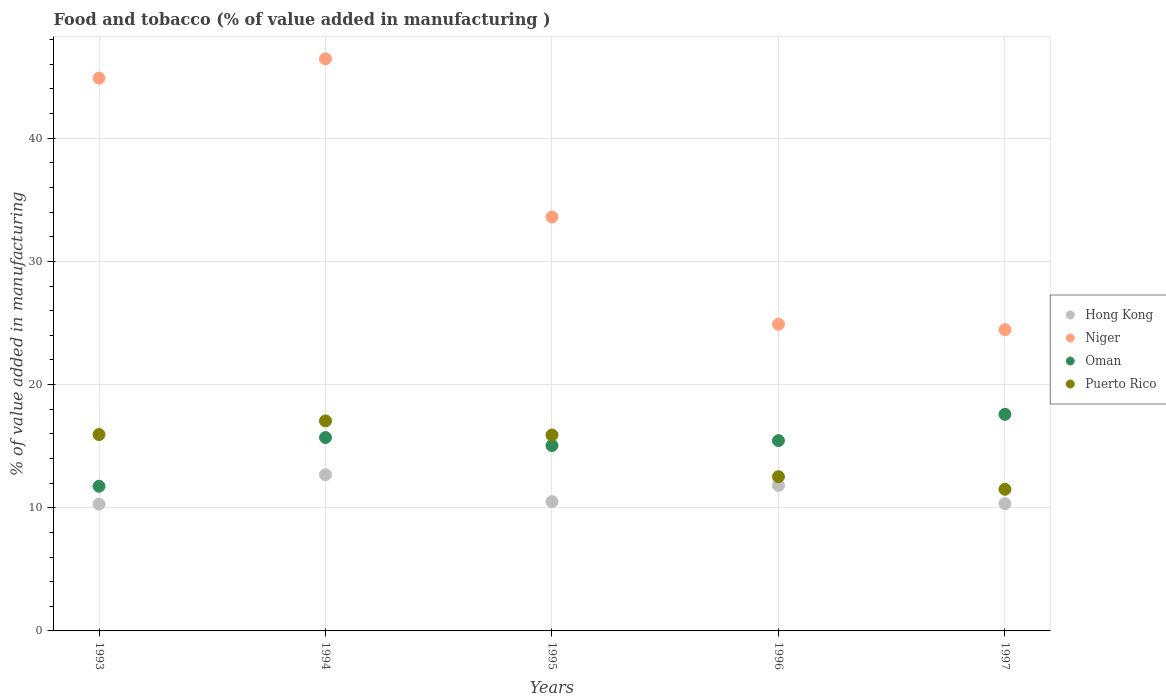How many different coloured dotlines are there?
Provide a succinct answer. 4. What is the value added in manufacturing food and tobacco in Oman in 1997?
Offer a very short reply. 17.58. Across all years, what is the maximum value added in manufacturing food and tobacco in Puerto Rico?
Ensure brevity in your answer.  17.05. Across all years, what is the minimum value added in manufacturing food and tobacco in Niger?
Ensure brevity in your answer.  24.46. In which year was the value added in manufacturing food and tobacco in Puerto Rico maximum?
Keep it short and to the point. 1994. In which year was the value added in manufacturing food and tobacco in Puerto Rico minimum?
Keep it short and to the point. 1997. What is the total value added in manufacturing food and tobacco in Puerto Rico in the graph?
Offer a very short reply. 72.92. What is the difference between the value added in manufacturing food and tobacco in Puerto Rico in 1995 and that in 1996?
Your answer should be very brief. 3.38. What is the difference between the value added in manufacturing food and tobacco in Niger in 1995 and the value added in manufacturing food and tobacco in Oman in 1996?
Keep it short and to the point. 18.16. What is the average value added in manufacturing food and tobacco in Oman per year?
Provide a short and direct response. 15.1. In the year 1997, what is the difference between the value added in manufacturing food and tobacco in Hong Kong and value added in manufacturing food and tobacco in Niger?
Ensure brevity in your answer.  -14.12. What is the ratio of the value added in manufacturing food and tobacco in Puerto Rico in 1994 to that in 1995?
Your response must be concise. 1.07. What is the difference between the highest and the second highest value added in manufacturing food and tobacco in Oman?
Keep it short and to the point. 1.88. What is the difference between the highest and the lowest value added in manufacturing food and tobacco in Oman?
Your answer should be very brief. 5.84. In how many years, is the value added in manufacturing food and tobacco in Oman greater than the average value added in manufacturing food and tobacco in Oman taken over all years?
Provide a succinct answer. 3. Is it the case that in every year, the sum of the value added in manufacturing food and tobacco in Hong Kong and value added in manufacturing food and tobacco in Puerto Rico  is greater than the value added in manufacturing food and tobacco in Niger?
Keep it short and to the point. No. Does the value added in manufacturing food and tobacco in Hong Kong monotonically increase over the years?
Provide a short and direct response. No. Is the value added in manufacturing food and tobacco in Niger strictly greater than the value added in manufacturing food and tobacco in Puerto Rico over the years?
Ensure brevity in your answer.  Yes. How many years are there in the graph?
Offer a terse response. 5. Does the graph contain any zero values?
Give a very brief answer. No. Does the graph contain grids?
Your answer should be compact. Yes. Where does the legend appear in the graph?
Your answer should be compact. Center right. How many legend labels are there?
Your answer should be very brief. 4. What is the title of the graph?
Provide a succinct answer. Food and tobacco (% of value added in manufacturing ). Does "Latin America(developing only)" appear as one of the legend labels in the graph?
Your answer should be very brief. No. What is the label or title of the Y-axis?
Your response must be concise. % of value added in manufacturing. What is the % of value added in manufacturing of Hong Kong in 1993?
Your answer should be very brief. 10.29. What is the % of value added in manufacturing of Niger in 1993?
Offer a very short reply. 44.87. What is the % of value added in manufacturing in Oman in 1993?
Ensure brevity in your answer.  11.75. What is the % of value added in manufacturing of Puerto Rico in 1993?
Provide a short and direct response. 15.94. What is the % of value added in manufacturing in Hong Kong in 1994?
Keep it short and to the point. 12.68. What is the % of value added in manufacturing of Niger in 1994?
Your answer should be very brief. 46.44. What is the % of value added in manufacturing in Oman in 1994?
Keep it short and to the point. 15.7. What is the % of value added in manufacturing in Puerto Rico in 1994?
Make the answer very short. 17.05. What is the % of value added in manufacturing in Hong Kong in 1995?
Make the answer very short. 10.5. What is the % of value added in manufacturing of Niger in 1995?
Make the answer very short. 33.6. What is the % of value added in manufacturing in Oman in 1995?
Ensure brevity in your answer.  15.05. What is the % of value added in manufacturing in Puerto Rico in 1995?
Provide a short and direct response. 15.91. What is the % of value added in manufacturing in Hong Kong in 1996?
Provide a succinct answer. 11.8. What is the % of value added in manufacturing of Niger in 1996?
Keep it short and to the point. 24.9. What is the % of value added in manufacturing in Oman in 1996?
Provide a short and direct response. 15.45. What is the % of value added in manufacturing in Puerto Rico in 1996?
Offer a terse response. 12.52. What is the % of value added in manufacturing of Hong Kong in 1997?
Make the answer very short. 10.33. What is the % of value added in manufacturing of Niger in 1997?
Keep it short and to the point. 24.46. What is the % of value added in manufacturing of Oman in 1997?
Make the answer very short. 17.58. What is the % of value added in manufacturing in Puerto Rico in 1997?
Make the answer very short. 11.5. Across all years, what is the maximum % of value added in manufacturing of Hong Kong?
Your answer should be compact. 12.68. Across all years, what is the maximum % of value added in manufacturing of Niger?
Provide a short and direct response. 46.44. Across all years, what is the maximum % of value added in manufacturing of Oman?
Give a very brief answer. 17.58. Across all years, what is the maximum % of value added in manufacturing in Puerto Rico?
Offer a terse response. 17.05. Across all years, what is the minimum % of value added in manufacturing in Hong Kong?
Provide a succinct answer. 10.29. Across all years, what is the minimum % of value added in manufacturing of Niger?
Offer a very short reply. 24.46. Across all years, what is the minimum % of value added in manufacturing in Oman?
Your response must be concise. 11.75. Across all years, what is the minimum % of value added in manufacturing of Puerto Rico?
Your answer should be very brief. 11.5. What is the total % of value added in manufacturing of Hong Kong in the graph?
Give a very brief answer. 55.61. What is the total % of value added in manufacturing of Niger in the graph?
Your answer should be very brief. 174.27. What is the total % of value added in manufacturing in Oman in the graph?
Keep it short and to the point. 75.52. What is the total % of value added in manufacturing in Puerto Rico in the graph?
Your answer should be compact. 72.92. What is the difference between the % of value added in manufacturing of Hong Kong in 1993 and that in 1994?
Offer a very short reply. -2.39. What is the difference between the % of value added in manufacturing of Niger in 1993 and that in 1994?
Offer a terse response. -1.57. What is the difference between the % of value added in manufacturing in Oman in 1993 and that in 1994?
Your response must be concise. -3.95. What is the difference between the % of value added in manufacturing of Puerto Rico in 1993 and that in 1994?
Your answer should be compact. -1.1. What is the difference between the % of value added in manufacturing in Hong Kong in 1993 and that in 1995?
Give a very brief answer. -0.21. What is the difference between the % of value added in manufacturing of Niger in 1993 and that in 1995?
Your response must be concise. 11.27. What is the difference between the % of value added in manufacturing of Oman in 1993 and that in 1995?
Make the answer very short. -3.31. What is the difference between the % of value added in manufacturing of Puerto Rico in 1993 and that in 1995?
Provide a short and direct response. 0.04. What is the difference between the % of value added in manufacturing in Hong Kong in 1993 and that in 1996?
Offer a terse response. -1.51. What is the difference between the % of value added in manufacturing in Niger in 1993 and that in 1996?
Your answer should be compact. 19.98. What is the difference between the % of value added in manufacturing in Oman in 1993 and that in 1996?
Provide a succinct answer. -3.7. What is the difference between the % of value added in manufacturing of Puerto Rico in 1993 and that in 1996?
Offer a very short reply. 3.42. What is the difference between the % of value added in manufacturing of Hong Kong in 1993 and that in 1997?
Your answer should be very brief. -0.04. What is the difference between the % of value added in manufacturing in Niger in 1993 and that in 1997?
Offer a terse response. 20.42. What is the difference between the % of value added in manufacturing in Oman in 1993 and that in 1997?
Make the answer very short. -5.84. What is the difference between the % of value added in manufacturing of Puerto Rico in 1993 and that in 1997?
Ensure brevity in your answer.  4.44. What is the difference between the % of value added in manufacturing in Hong Kong in 1994 and that in 1995?
Make the answer very short. 2.18. What is the difference between the % of value added in manufacturing in Niger in 1994 and that in 1995?
Offer a terse response. 12.84. What is the difference between the % of value added in manufacturing in Oman in 1994 and that in 1995?
Give a very brief answer. 0.65. What is the difference between the % of value added in manufacturing of Puerto Rico in 1994 and that in 1995?
Keep it short and to the point. 1.14. What is the difference between the % of value added in manufacturing of Hong Kong in 1994 and that in 1996?
Keep it short and to the point. 0.88. What is the difference between the % of value added in manufacturing in Niger in 1994 and that in 1996?
Your response must be concise. 21.55. What is the difference between the % of value added in manufacturing of Oman in 1994 and that in 1996?
Your answer should be compact. 0.25. What is the difference between the % of value added in manufacturing in Puerto Rico in 1994 and that in 1996?
Your response must be concise. 4.53. What is the difference between the % of value added in manufacturing of Hong Kong in 1994 and that in 1997?
Ensure brevity in your answer.  2.35. What is the difference between the % of value added in manufacturing of Niger in 1994 and that in 1997?
Your response must be concise. 21.99. What is the difference between the % of value added in manufacturing of Oman in 1994 and that in 1997?
Offer a very short reply. -1.88. What is the difference between the % of value added in manufacturing of Puerto Rico in 1994 and that in 1997?
Ensure brevity in your answer.  5.55. What is the difference between the % of value added in manufacturing in Hong Kong in 1995 and that in 1996?
Your answer should be very brief. -1.3. What is the difference between the % of value added in manufacturing of Niger in 1995 and that in 1996?
Keep it short and to the point. 8.71. What is the difference between the % of value added in manufacturing in Oman in 1995 and that in 1996?
Offer a terse response. -0.4. What is the difference between the % of value added in manufacturing in Puerto Rico in 1995 and that in 1996?
Make the answer very short. 3.38. What is the difference between the % of value added in manufacturing in Hong Kong in 1995 and that in 1997?
Offer a very short reply. 0.17. What is the difference between the % of value added in manufacturing of Niger in 1995 and that in 1997?
Offer a very short reply. 9.15. What is the difference between the % of value added in manufacturing in Oman in 1995 and that in 1997?
Your answer should be compact. -2.53. What is the difference between the % of value added in manufacturing of Puerto Rico in 1995 and that in 1997?
Provide a succinct answer. 4.4. What is the difference between the % of value added in manufacturing in Hong Kong in 1996 and that in 1997?
Your answer should be very brief. 1.47. What is the difference between the % of value added in manufacturing in Niger in 1996 and that in 1997?
Provide a succinct answer. 0.44. What is the difference between the % of value added in manufacturing of Oman in 1996 and that in 1997?
Offer a terse response. -2.13. What is the difference between the % of value added in manufacturing of Puerto Rico in 1996 and that in 1997?
Your answer should be compact. 1.02. What is the difference between the % of value added in manufacturing in Hong Kong in 1993 and the % of value added in manufacturing in Niger in 1994?
Keep it short and to the point. -36.15. What is the difference between the % of value added in manufacturing of Hong Kong in 1993 and the % of value added in manufacturing of Oman in 1994?
Provide a short and direct response. -5.41. What is the difference between the % of value added in manufacturing in Hong Kong in 1993 and the % of value added in manufacturing in Puerto Rico in 1994?
Offer a terse response. -6.76. What is the difference between the % of value added in manufacturing of Niger in 1993 and the % of value added in manufacturing of Oman in 1994?
Your answer should be compact. 29.18. What is the difference between the % of value added in manufacturing in Niger in 1993 and the % of value added in manufacturing in Puerto Rico in 1994?
Offer a terse response. 27.82. What is the difference between the % of value added in manufacturing of Oman in 1993 and the % of value added in manufacturing of Puerto Rico in 1994?
Your answer should be very brief. -5.3. What is the difference between the % of value added in manufacturing in Hong Kong in 1993 and the % of value added in manufacturing in Niger in 1995?
Your answer should be compact. -23.31. What is the difference between the % of value added in manufacturing of Hong Kong in 1993 and the % of value added in manufacturing of Oman in 1995?
Give a very brief answer. -4.76. What is the difference between the % of value added in manufacturing in Hong Kong in 1993 and the % of value added in manufacturing in Puerto Rico in 1995?
Ensure brevity in your answer.  -5.61. What is the difference between the % of value added in manufacturing in Niger in 1993 and the % of value added in manufacturing in Oman in 1995?
Offer a very short reply. 29.82. What is the difference between the % of value added in manufacturing of Niger in 1993 and the % of value added in manufacturing of Puerto Rico in 1995?
Offer a very short reply. 28.97. What is the difference between the % of value added in manufacturing in Oman in 1993 and the % of value added in manufacturing in Puerto Rico in 1995?
Offer a very short reply. -4.16. What is the difference between the % of value added in manufacturing of Hong Kong in 1993 and the % of value added in manufacturing of Niger in 1996?
Your response must be concise. -14.61. What is the difference between the % of value added in manufacturing in Hong Kong in 1993 and the % of value added in manufacturing in Oman in 1996?
Your answer should be compact. -5.16. What is the difference between the % of value added in manufacturing of Hong Kong in 1993 and the % of value added in manufacturing of Puerto Rico in 1996?
Make the answer very short. -2.23. What is the difference between the % of value added in manufacturing of Niger in 1993 and the % of value added in manufacturing of Oman in 1996?
Provide a short and direct response. 29.42. What is the difference between the % of value added in manufacturing of Niger in 1993 and the % of value added in manufacturing of Puerto Rico in 1996?
Offer a very short reply. 32.35. What is the difference between the % of value added in manufacturing of Oman in 1993 and the % of value added in manufacturing of Puerto Rico in 1996?
Provide a succinct answer. -0.77. What is the difference between the % of value added in manufacturing of Hong Kong in 1993 and the % of value added in manufacturing of Niger in 1997?
Provide a succinct answer. -14.17. What is the difference between the % of value added in manufacturing of Hong Kong in 1993 and the % of value added in manufacturing of Oman in 1997?
Make the answer very short. -7.29. What is the difference between the % of value added in manufacturing in Hong Kong in 1993 and the % of value added in manufacturing in Puerto Rico in 1997?
Give a very brief answer. -1.21. What is the difference between the % of value added in manufacturing of Niger in 1993 and the % of value added in manufacturing of Oman in 1997?
Make the answer very short. 27.29. What is the difference between the % of value added in manufacturing of Niger in 1993 and the % of value added in manufacturing of Puerto Rico in 1997?
Offer a terse response. 33.37. What is the difference between the % of value added in manufacturing in Oman in 1993 and the % of value added in manufacturing in Puerto Rico in 1997?
Make the answer very short. 0.24. What is the difference between the % of value added in manufacturing in Hong Kong in 1994 and the % of value added in manufacturing in Niger in 1995?
Your answer should be compact. -20.93. What is the difference between the % of value added in manufacturing of Hong Kong in 1994 and the % of value added in manufacturing of Oman in 1995?
Ensure brevity in your answer.  -2.37. What is the difference between the % of value added in manufacturing in Hong Kong in 1994 and the % of value added in manufacturing in Puerto Rico in 1995?
Your response must be concise. -3.23. What is the difference between the % of value added in manufacturing of Niger in 1994 and the % of value added in manufacturing of Oman in 1995?
Your response must be concise. 31.39. What is the difference between the % of value added in manufacturing in Niger in 1994 and the % of value added in manufacturing in Puerto Rico in 1995?
Keep it short and to the point. 30.54. What is the difference between the % of value added in manufacturing of Oman in 1994 and the % of value added in manufacturing of Puerto Rico in 1995?
Your response must be concise. -0.21. What is the difference between the % of value added in manufacturing of Hong Kong in 1994 and the % of value added in manufacturing of Niger in 1996?
Your response must be concise. -12.22. What is the difference between the % of value added in manufacturing in Hong Kong in 1994 and the % of value added in manufacturing in Oman in 1996?
Your answer should be compact. -2.77. What is the difference between the % of value added in manufacturing of Hong Kong in 1994 and the % of value added in manufacturing of Puerto Rico in 1996?
Make the answer very short. 0.16. What is the difference between the % of value added in manufacturing of Niger in 1994 and the % of value added in manufacturing of Oman in 1996?
Offer a terse response. 30.99. What is the difference between the % of value added in manufacturing of Niger in 1994 and the % of value added in manufacturing of Puerto Rico in 1996?
Your response must be concise. 33.92. What is the difference between the % of value added in manufacturing in Oman in 1994 and the % of value added in manufacturing in Puerto Rico in 1996?
Provide a short and direct response. 3.18. What is the difference between the % of value added in manufacturing of Hong Kong in 1994 and the % of value added in manufacturing of Niger in 1997?
Give a very brief answer. -11.78. What is the difference between the % of value added in manufacturing in Hong Kong in 1994 and the % of value added in manufacturing in Oman in 1997?
Offer a very short reply. -4.9. What is the difference between the % of value added in manufacturing in Hong Kong in 1994 and the % of value added in manufacturing in Puerto Rico in 1997?
Your response must be concise. 1.18. What is the difference between the % of value added in manufacturing in Niger in 1994 and the % of value added in manufacturing in Oman in 1997?
Provide a short and direct response. 28.86. What is the difference between the % of value added in manufacturing of Niger in 1994 and the % of value added in manufacturing of Puerto Rico in 1997?
Your response must be concise. 34.94. What is the difference between the % of value added in manufacturing in Oman in 1994 and the % of value added in manufacturing in Puerto Rico in 1997?
Provide a succinct answer. 4.2. What is the difference between the % of value added in manufacturing of Hong Kong in 1995 and the % of value added in manufacturing of Niger in 1996?
Your response must be concise. -14.4. What is the difference between the % of value added in manufacturing in Hong Kong in 1995 and the % of value added in manufacturing in Oman in 1996?
Ensure brevity in your answer.  -4.95. What is the difference between the % of value added in manufacturing in Hong Kong in 1995 and the % of value added in manufacturing in Puerto Rico in 1996?
Make the answer very short. -2.02. What is the difference between the % of value added in manufacturing in Niger in 1995 and the % of value added in manufacturing in Oman in 1996?
Make the answer very short. 18.16. What is the difference between the % of value added in manufacturing of Niger in 1995 and the % of value added in manufacturing of Puerto Rico in 1996?
Provide a succinct answer. 21.08. What is the difference between the % of value added in manufacturing in Oman in 1995 and the % of value added in manufacturing in Puerto Rico in 1996?
Offer a terse response. 2.53. What is the difference between the % of value added in manufacturing in Hong Kong in 1995 and the % of value added in manufacturing in Niger in 1997?
Your answer should be compact. -13.96. What is the difference between the % of value added in manufacturing in Hong Kong in 1995 and the % of value added in manufacturing in Oman in 1997?
Your answer should be compact. -7.08. What is the difference between the % of value added in manufacturing of Hong Kong in 1995 and the % of value added in manufacturing of Puerto Rico in 1997?
Keep it short and to the point. -1. What is the difference between the % of value added in manufacturing in Niger in 1995 and the % of value added in manufacturing in Oman in 1997?
Your answer should be very brief. 16.02. What is the difference between the % of value added in manufacturing of Niger in 1995 and the % of value added in manufacturing of Puerto Rico in 1997?
Offer a terse response. 22.1. What is the difference between the % of value added in manufacturing in Oman in 1995 and the % of value added in manufacturing in Puerto Rico in 1997?
Provide a succinct answer. 3.55. What is the difference between the % of value added in manufacturing of Hong Kong in 1996 and the % of value added in manufacturing of Niger in 1997?
Make the answer very short. -12.65. What is the difference between the % of value added in manufacturing in Hong Kong in 1996 and the % of value added in manufacturing in Oman in 1997?
Your answer should be very brief. -5.78. What is the difference between the % of value added in manufacturing of Hong Kong in 1996 and the % of value added in manufacturing of Puerto Rico in 1997?
Your answer should be very brief. 0.3. What is the difference between the % of value added in manufacturing of Niger in 1996 and the % of value added in manufacturing of Oman in 1997?
Provide a short and direct response. 7.32. What is the difference between the % of value added in manufacturing in Niger in 1996 and the % of value added in manufacturing in Puerto Rico in 1997?
Ensure brevity in your answer.  13.4. What is the difference between the % of value added in manufacturing of Oman in 1996 and the % of value added in manufacturing of Puerto Rico in 1997?
Your answer should be very brief. 3.95. What is the average % of value added in manufacturing of Hong Kong per year?
Offer a very short reply. 11.12. What is the average % of value added in manufacturing of Niger per year?
Offer a terse response. 34.85. What is the average % of value added in manufacturing of Oman per year?
Keep it short and to the point. 15.1. What is the average % of value added in manufacturing of Puerto Rico per year?
Your response must be concise. 14.58. In the year 1993, what is the difference between the % of value added in manufacturing of Hong Kong and % of value added in manufacturing of Niger?
Your response must be concise. -34.58. In the year 1993, what is the difference between the % of value added in manufacturing in Hong Kong and % of value added in manufacturing in Oman?
Provide a short and direct response. -1.46. In the year 1993, what is the difference between the % of value added in manufacturing of Hong Kong and % of value added in manufacturing of Puerto Rico?
Provide a short and direct response. -5.65. In the year 1993, what is the difference between the % of value added in manufacturing in Niger and % of value added in manufacturing in Oman?
Your answer should be very brief. 33.13. In the year 1993, what is the difference between the % of value added in manufacturing of Niger and % of value added in manufacturing of Puerto Rico?
Provide a succinct answer. 28.93. In the year 1993, what is the difference between the % of value added in manufacturing of Oman and % of value added in manufacturing of Puerto Rico?
Your answer should be compact. -4.2. In the year 1994, what is the difference between the % of value added in manufacturing of Hong Kong and % of value added in manufacturing of Niger?
Offer a terse response. -33.76. In the year 1994, what is the difference between the % of value added in manufacturing in Hong Kong and % of value added in manufacturing in Oman?
Offer a very short reply. -3.02. In the year 1994, what is the difference between the % of value added in manufacturing in Hong Kong and % of value added in manufacturing in Puerto Rico?
Provide a succinct answer. -4.37. In the year 1994, what is the difference between the % of value added in manufacturing of Niger and % of value added in manufacturing of Oman?
Provide a short and direct response. 30.75. In the year 1994, what is the difference between the % of value added in manufacturing of Niger and % of value added in manufacturing of Puerto Rico?
Your answer should be compact. 29.39. In the year 1994, what is the difference between the % of value added in manufacturing in Oman and % of value added in manufacturing in Puerto Rico?
Offer a very short reply. -1.35. In the year 1995, what is the difference between the % of value added in manufacturing of Hong Kong and % of value added in manufacturing of Niger?
Your answer should be very brief. -23.11. In the year 1995, what is the difference between the % of value added in manufacturing of Hong Kong and % of value added in manufacturing of Oman?
Make the answer very short. -4.55. In the year 1995, what is the difference between the % of value added in manufacturing in Hong Kong and % of value added in manufacturing in Puerto Rico?
Ensure brevity in your answer.  -5.41. In the year 1995, what is the difference between the % of value added in manufacturing of Niger and % of value added in manufacturing of Oman?
Make the answer very short. 18.55. In the year 1995, what is the difference between the % of value added in manufacturing in Niger and % of value added in manufacturing in Puerto Rico?
Offer a terse response. 17.7. In the year 1995, what is the difference between the % of value added in manufacturing in Oman and % of value added in manufacturing in Puerto Rico?
Ensure brevity in your answer.  -0.85. In the year 1996, what is the difference between the % of value added in manufacturing in Hong Kong and % of value added in manufacturing in Niger?
Provide a succinct answer. -13.09. In the year 1996, what is the difference between the % of value added in manufacturing in Hong Kong and % of value added in manufacturing in Oman?
Your answer should be compact. -3.64. In the year 1996, what is the difference between the % of value added in manufacturing in Hong Kong and % of value added in manufacturing in Puerto Rico?
Keep it short and to the point. -0.72. In the year 1996, what is the difference between the % of value added in manufacturing in Niger and % of value added in manufacturing in Oman?
Keep it short and to the point. 9.45. In the year 1996, what is the difference between the % of value added in manufacturing in Niger and % of value added in manufacturing in Puerto Rico?
Offer a terse response. 12.38. In the year 1996, what is the difference between the % of value added in manufacturing in Oman and % of value added in manufacturing in Puerto Rico?
Your answer should be compact. 2.93. In the year 1997, what is the difference between the % of value added in manufacturing in Hong Kong and % of value added in manufacturing in Niger?
Provide a short and direct response. -14.12. In the year 1997, what is the difference between the % of value added in manufacturing of Hong Kong and % of value added in manufacturing of Oman?
Offer a very short reply. -7.25. In the year 1997, what is the difference between the % of value added in manufacturing in Hong Kong and % of value added in manufacturing in Puerto Rico?
Provide a succinct answer. -1.17. In the year 1997, what is the difference between the % of value added in manufacturing in Niger and % of value added in manufacturing in Oman?
Give a very brief answer. 6.87. In the year 1997, what is the difference between the % of value added in manufacturing of Niger and % of value added in manufacturing of Puerto Rico?
Give a very brief answer. 12.96. In the year 1997, what is the difference between the % of value added in manufacturing of Oman and % of value added in manufacturing of Puerto Rico?
Your answer should be compact. 6.08. What is the ratio of the % of value added in manufacturing in Hong Kong in 1993 to that in 1994?
Your answer should be compact. 0.81. What is the ratio of the % of value added in manufacturing of Niger in 1993 to that in 1994?
Provide a succinct answer. 0.97. What is the ratio of the % of value added in manufacturing of Oman in 1993 to that in 1994?
Your answer should be very brief. 0.75. What is the ratio of the % of value added in manufacturing of Puerto Rico in 1993 to that in 1994?
Provide a short and direct response. 0.94. What is the ratio of the % of value added in manufacturing in Hong Kong in 1993 to that in 1995?
Offer a terse response. 0.98. What is the ratio of the % of value added in manufacturing of Niger in 1993 to that in 1995?
Offer a very short reply. 1.34. What is the ratio of the % of value added in manufacturing of Oman in 1993 to that in 1995?
Your answer should be very brief. 0.78. What is the ratio of the % of value added in manufacturing of Puerto Rico in 1993 to that in 1995?
Your answer should be compact. 1. What is the ratio of the % of value added in manufacturing of Hong Kong in 1993 to that in 1996?
Offer a very short reply. 0.87. What is the ratio of the % of value added in manufacturing of Niger in 1993 to that in 1996?
Provide a short and direct response. 1.8. What is the ratio of the % of value added in manufacturing in Oman in 1993 to that in 1996?
Your answer should be compact. 0.76. What is the ratio of the % of value added in manufacturing of Puerto Rico in 1993 to that in 1996?
Give a very brief answer. 1.27. What is the ratio of the % of value added in manufacturing of Niger in 1993 to that in 1997?
Your response must be concise. 1.83. What is the ratio of the % of value added in manufacturing in Oman in 1993 to that in 1997?
Your answer should be compact. 0.67. What is the ratio of the % of value added in manufacturing of Puerto Rico in 1993 to that in 1997?
Offer a very short reply. 1.39. What is the ratio of the % of value added in manufacturing of Hong Kong in 1994 to that in 1995?
Your answer should be very brief. 1.21. What is the ratio of the % of value added in manufacturing in Niger in 1994 to that in 1995?
Your answer should be compact. 1.38. What is the ratio of the % of value added in manufacturing of Oman in 1994 to that in 1995?
Ensure brevity in your answer.  1.04. What is the ratio of the % of value added in manufacturing in Puerto Rico in 1994 to that in 1995?
Your response must be concise. 1.07. What is the ratio of the % of value added in manufacturing in Hong Kong in 1994 to that in 1996?
Your answer should be very brief. 1.07. What is the ratio of the % of value added in manufacturing of Niger in 1994 to that in 1996?
Ensure brevity in your answer.  1.87. What is the ratio of the % of value added in manufacturing in Oman in 1994 to that in 1996?
Your response must be concise. 1.02. What is the ratio of the % of value added in manufacturing in Puerto Rico in 1994 to that in 1996?
Your response must be concise. 1.36. What is the ratio of the % of value added in manufacturing in Hong Kong in 1994 to that in 1997?
Ensure brevity in your answer.  1.23. What is the ratio of the % of value added in manufacturing of Niger in 1994 to that in 1997?
Provide a succinct answer. 1.9. What is the ratio of the % of value added in manufacturing in Oman in 1994 to that in 1997?
Your answer should be compact. 0.89. What is the ratio of the % of value added in manufacturing of Puerto Rico in 1994 to that in 1997?
Offer a very short reply. 1.48. What is the ratio of the % of value added in manufacturing of Hong Kong in 1995 to that in 1996?
Provide a succinct answer. 0.89. What is the ratio of the % of value added in manufacturing of Niger in 1995 to that in 1996?
Offer a very short reply. 1.35. What is the ratio of the % of value added in manufacturing in Oman in 1995 to that in 1996?
Your answer should be compact. 0.97. What is the ratio of the % of value added in manufacturing of Puerto Rico in 1995 to that in 1996?
Provide a succinct answer. 1.27. What is the ratio of the % of value added in manufacturing of Hong Kong in 1995 to that in 1997?
Keep it short and to the point. 1.02. What is the ratio of the % of value added in manufacturing in Niger in 1995 to that in 1997?
Ensure brevity in your answer.  1.37. What is the ratio of the % of value added in manufacturing of Oman in 1995 to that in 1997?
Ensure brevity in your answer.  0.86. What is the ratio of the % of value added in manufacturing in Puerto Rico in 1995 to that in 1997?
Your response must be concise. 1.38. What is the ratio of the % of value added in manufacturing of Hong Kong in 1996 to that in 1997?
Provide a succinct answer. 1.14. What is the ratio of the % of value added in manufacturing in Niger in 1996 to that in 1997?
Your answer should be compact. 1.02. What is the ratio of the % of value added in manufacturing in Oman in 1996 to that in 1997?
Your answer should be very brief. 0.88. What is the ratio of the % of value added in manufacturing of Puerto Rico in 1996 to that in 1997?
Provide a succinct answer. 1.09. What is the difference between the highest and the second highest % of value added in manufacturing in Hong Kong?
Give a very brief answer. 0.88. What is the difference between the highest and the second highest % of value added in manufacturing of Niger?
Your answer should be compact. 1.57. What is the difference between the highest and the second highest % of value added in manufacturing in Oman?
Keep it short and to the point. 1.88. What is the difference between the highest and the second highest % of value added in manufacturing of Puerto Rico?
Ensure brevity in your answer.  1.1. What is the difference between the highest and the lowest % of value added in manufacturing of Hong Kong?
Your answer should be very brief. 2.39. What is the difference between the highest and the lowest % of value added in manufacturing in Niger?
Provide a succinct answer. 21.99. What is the difference between the highest and the lowest % of value added in manufacturing in Oman?
Keep it short and to the point. 5.84. What is the difference between the highest and the lowest % of value added in manufacturing of Puerto Rico?
Your answer should be compact. 5.55. 